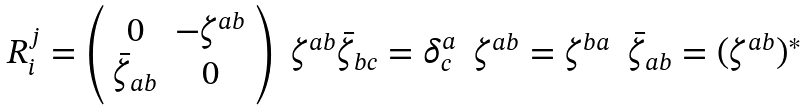<formula> <loc_0><loc_0><loc_500><loc_500>\begin{array} { c c c c } { { R _ { i } ^ { j } = \left ( \begin{array} { c c } { 0 } & { { - \zeta ^ { a b } } } \\ { { \bar { \zeta } _ { a b } } } & { 0 } \end{array} \right ) } } & { { \zeta ^ { a b } \bar { \zeta } _ { b c } = \delta _ { c } ^ { a } } } & { { \zeta ^ { a b } = \zeta ^ { b a } } } & { { \bar { \zeta } _ { a b } = ( \zeta ^ { a b } ) ^ { \ast } } } \end{array}</formula> 